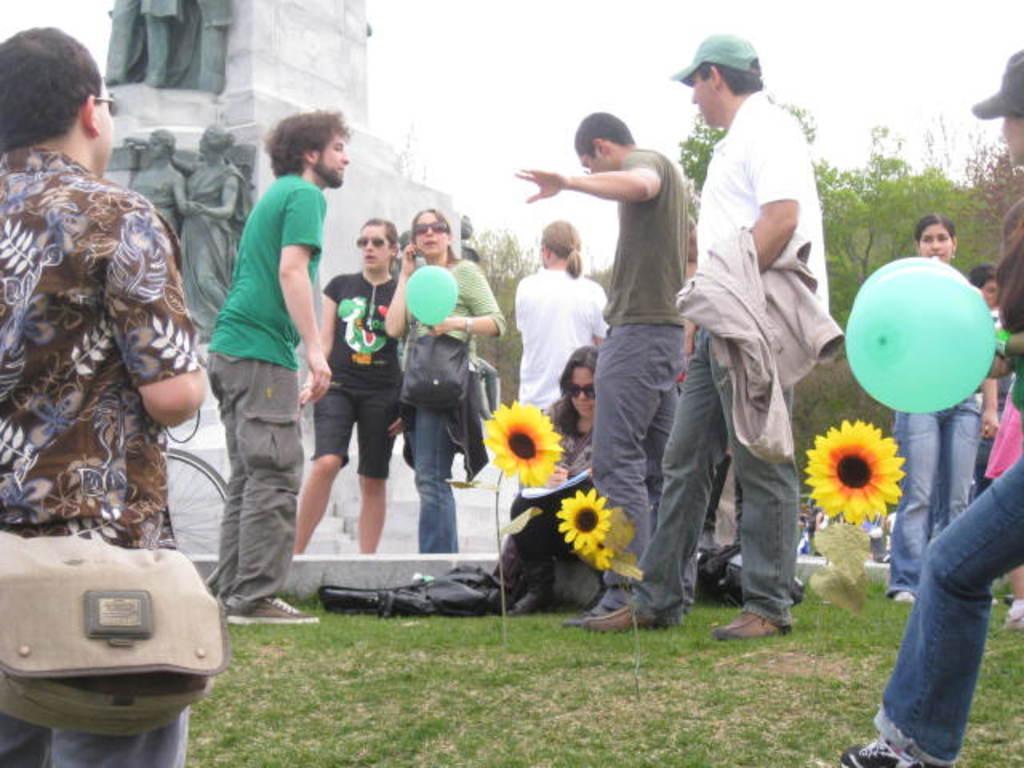Can you describe this image briefly? This is an outside view. On the right side there is a person holding balloons in the hands. On the left side there is a man wearing a bag and standing facing towards the back side. In the middle of the image I can see few people are standing and one woman is sitting on the ground and she is holding some objects. Here I can see three plants along with the flowers which are in yellow color. At the bottom, I can see the grass on the ground. At the back of these people there is a pillar on which I can see few sculptures. In the background there are many trees. At the top of the image I can see the sky. 